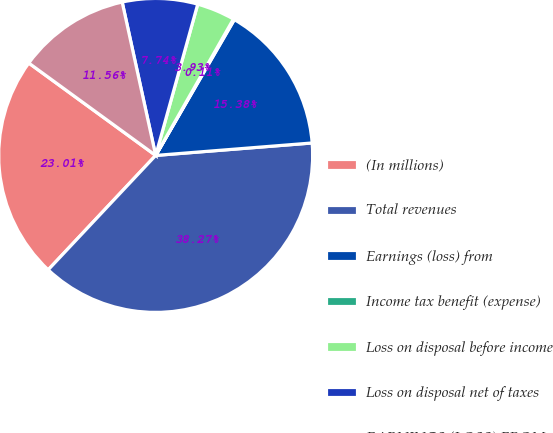<chart> <loc_0><loc_0><loc_500><loc_500><pie_chart><fcel>(In millions)<fcel>Total revenues<fcel>Earnings (loss) from<fcel>Income tax benefit (expense)<fcel>Loss on disposal before income<fcel>Loss on disposal net of taxes<fcel>EARNINGS (LOSS) FROM<nl><fcel>23.01%<fcel>38.27%<fcel>15.38%<fcel>0.11%<fcel>3.93%<fcel>7.74%<fcel>11.56%<nl></chart> 